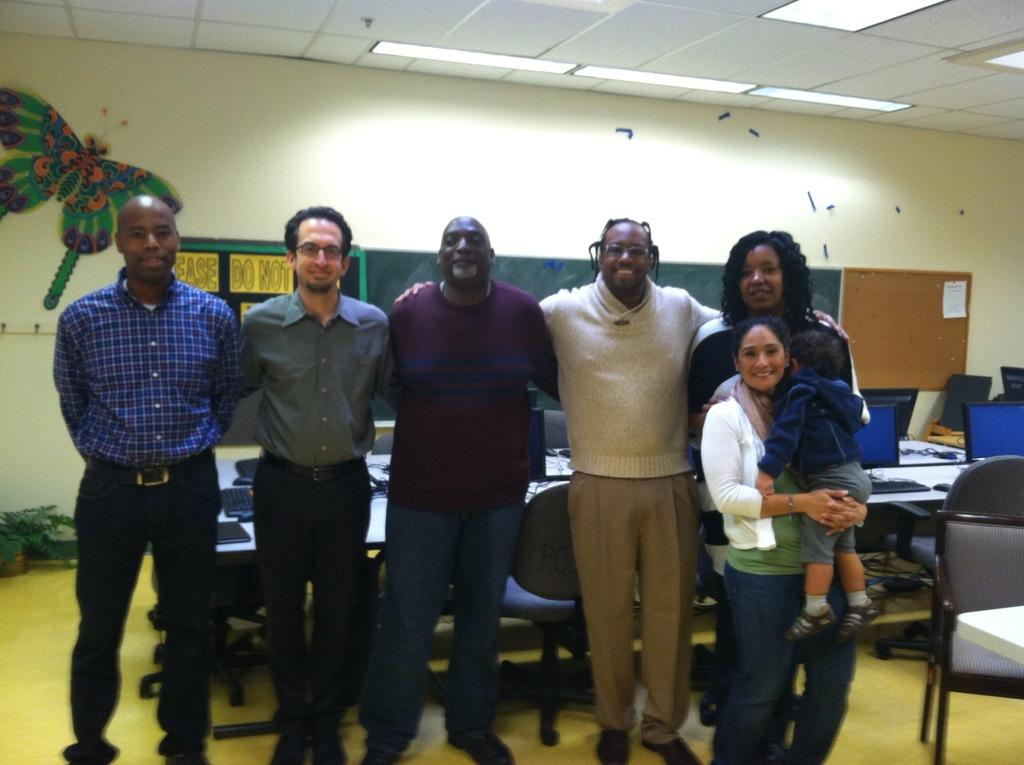What can be seen in the image? There are people standing in the image. What is visible in the background of the image? There is a wall in the background of the image. What is on the wall? There is a chart and a notice board on the wall. Can you see a tiger wearing a scarf in the image? No, there is no tiger or scarf present in the image. 